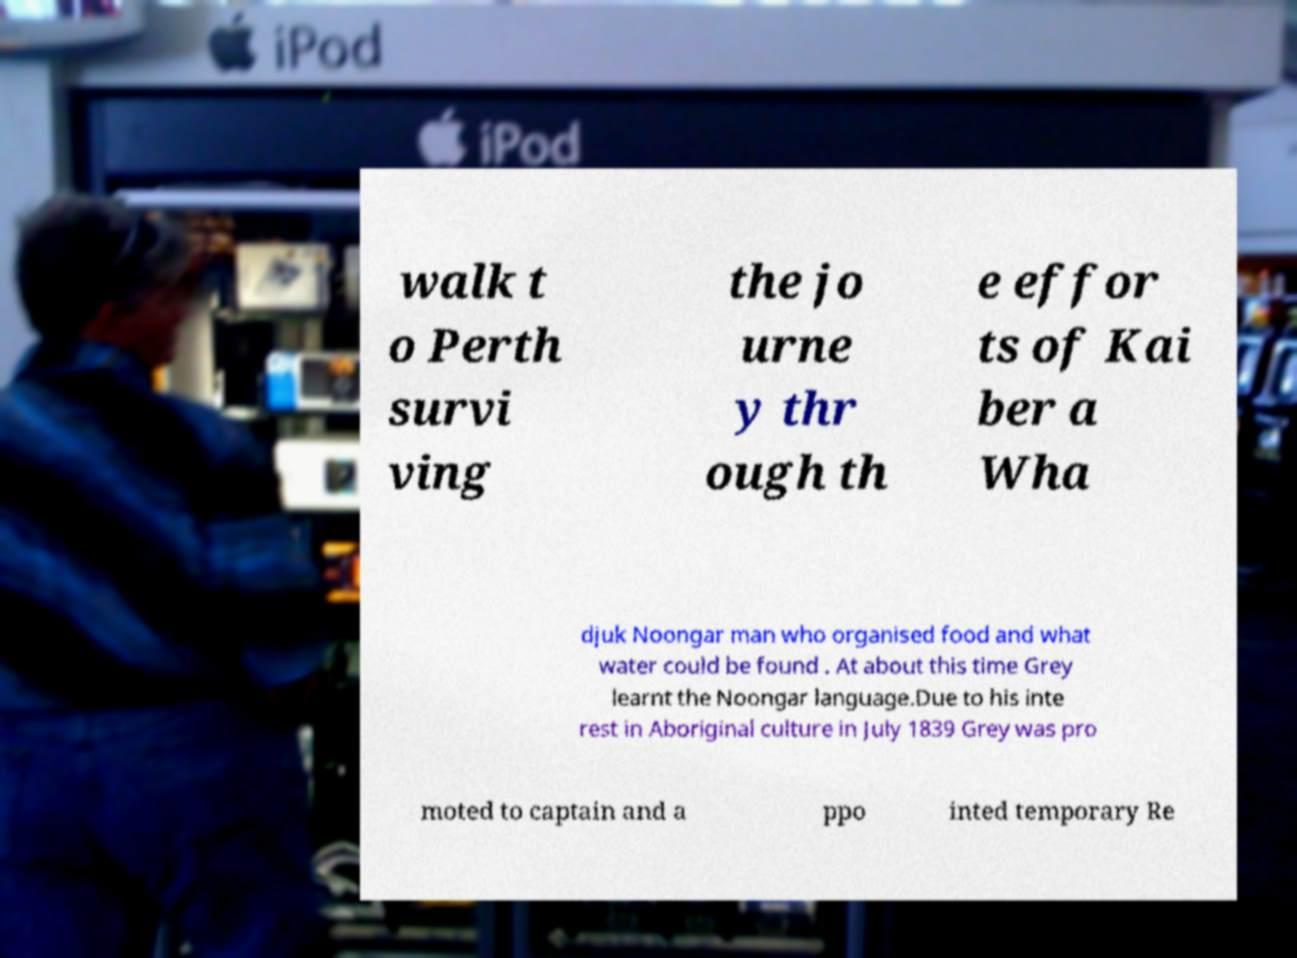Could you extract and type out the text from this image? walk t o Perth survi ving the jo urne y thr ough th e effor ts of Kai ber a Wha djuk Noongar man who organised food and what water could be found . At about this time Grey learnt the Noongar language.Due to his inte rest in Aboriginal culture in July 1839 Grey was pro moted to captain and a ppo inted temporary Re 